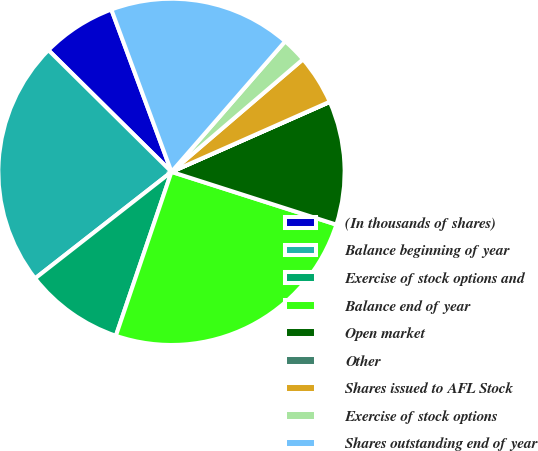Convert chart. <chart><loc_0><loc_0><loc_500><loc_500><pie_chart><fcel>(In thousands of shares)<fcel>Balance beginning of year<fcel>Exercise of stock options and<fcel>Balance end of year<fcel>Open market<fcel>Other<fcel>Shares issued to AFL Stock<fcel>Exercise of stock options<fcel>Shares outstanding end of year<nl><fcel>6.94%<fcel>22.97%<fcel>9.24%<fcel>25.28%<fcel>11.55%<fcel>0.02%<fcel>4.63%<fcel>2.33%<fcel>17.05%<nl></chart> 